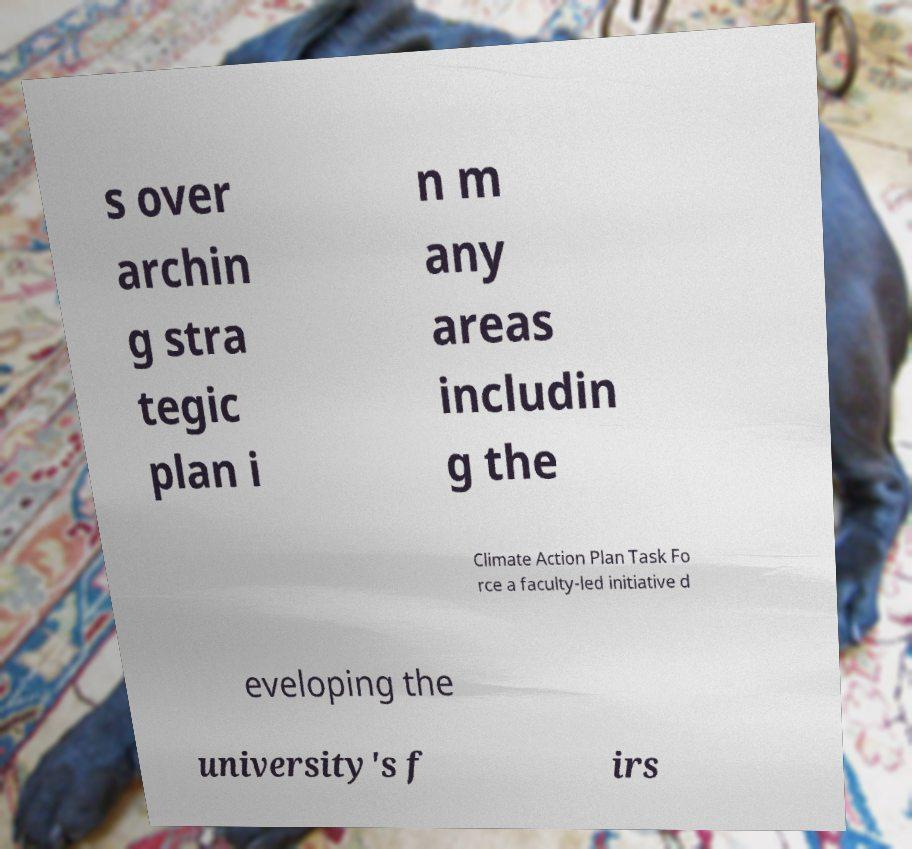Please identify and transcribe the text found in this image. s over archin g stra tegic plan i n m any areas includin g the Climate Action Plan Task Fo rce a faculty-led initiative d eveloping the university's f irs 